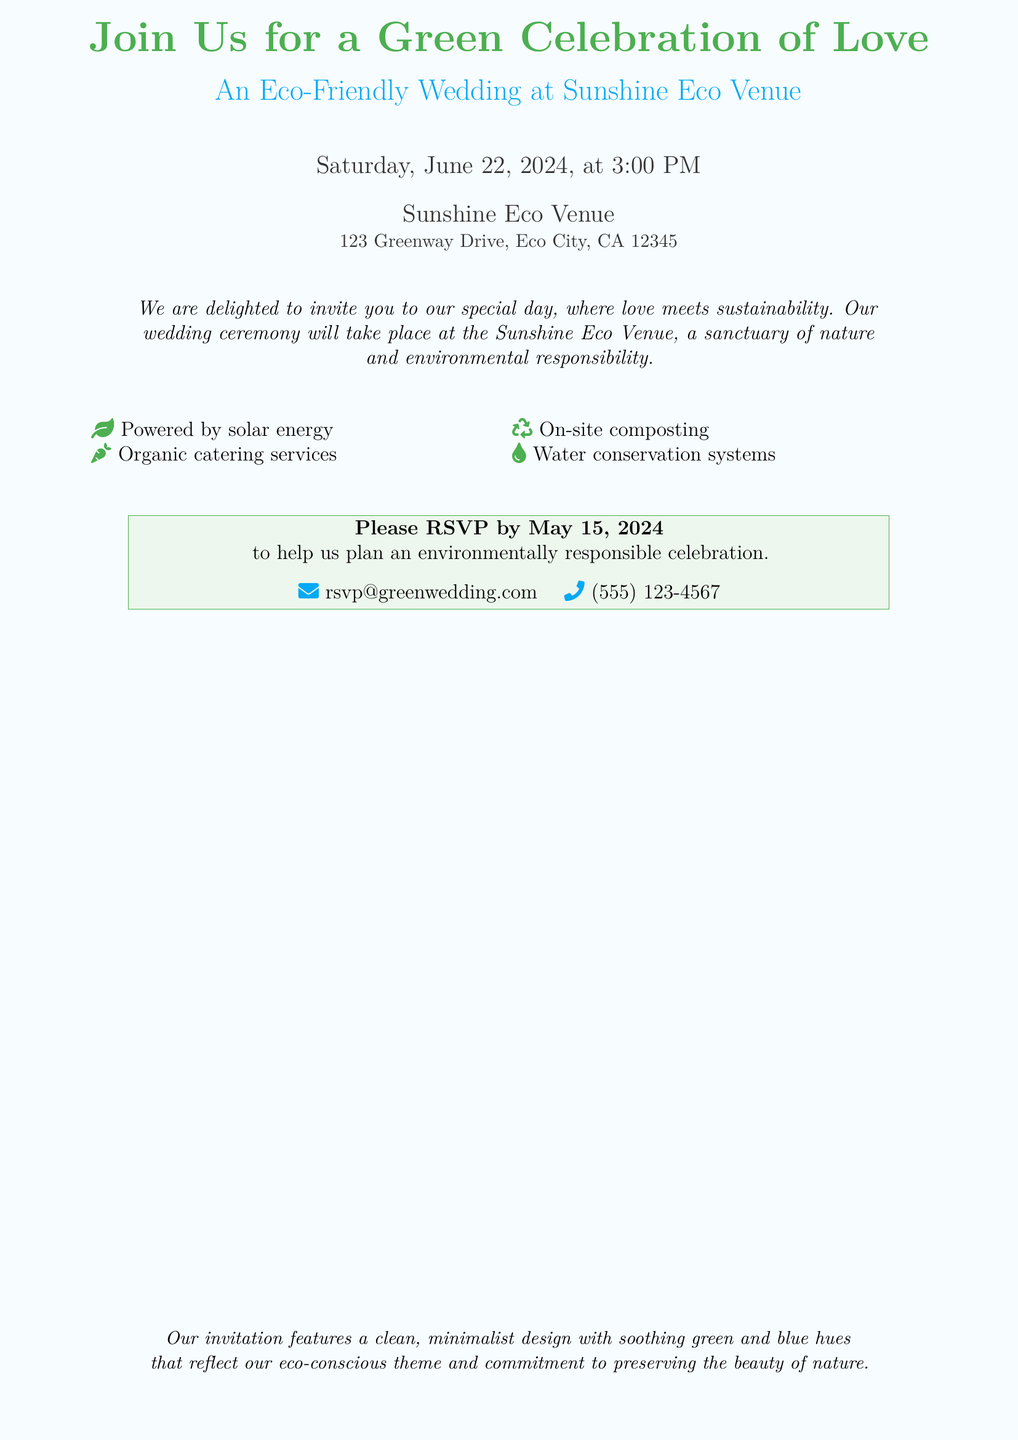What date is the wedding? The date of the wedding is explicitly mentioned in the document as Saturday, June 22, 2024.
Answer: June 22, 2024 What time does the wedding ceremony start? The starting time for the wedding ceremony is clearly stated in the document.
Answer: 3:00 PM Where is the wedding venue located? The specific location of the wedding venue is provided in the document.
Answer: 123 Greenway Drive, Eco City, CA 12345 What is one feature of the Sunshine Eco Venue? The document lists multiple features of the venue; one such feature is provided in the content.
Answer: Powered by solar energy Why is it important to RSVP by May 15, 2024? The document specifies that the RSVP is needed to plan an environmentally responsible celebration.
Answer: To help plan an environmentally responsible celebration What colors are used in the invitation design? The document describes the colors used in the invitation design to reflect the eco-conscious theme.
Answer: Green and blue hues What is the primary theme of the wedding? The invitation highlights a specific theme that combines love and nature.
Answer: Eco-Friendly What type of catering services will be provided? The document mentions the catering service type that aligns with the theme.
Answer: Organic catering services What environmental practice is used for waste management? The document lists a particular on-site practice for waste management at the venue.
Answer: On-site composting 